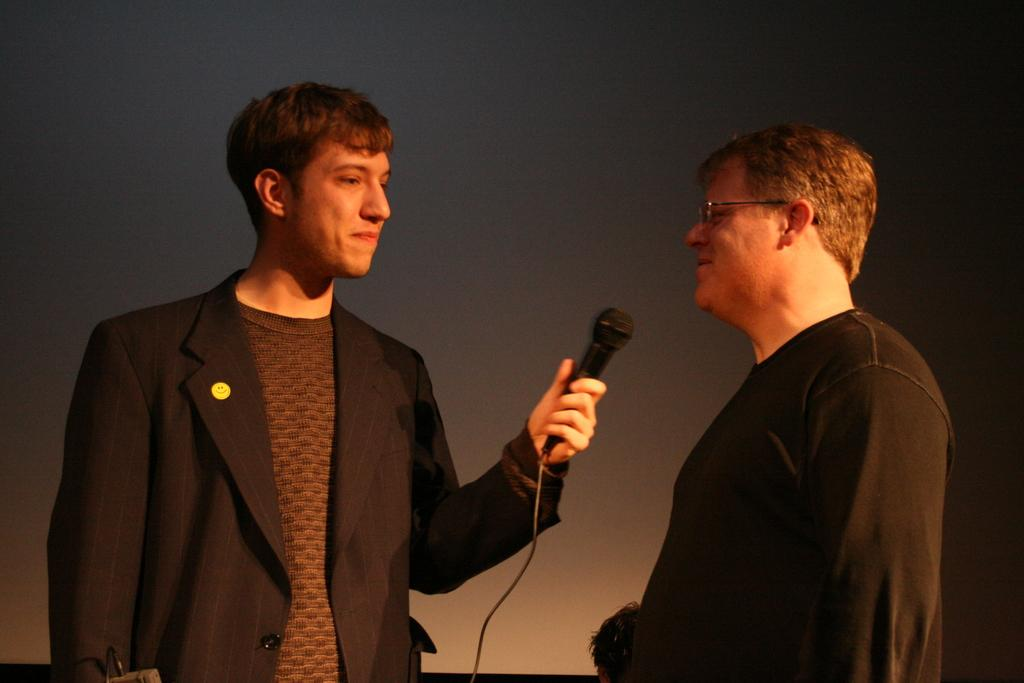How many people are in the image? There are two persons in the image. What are the two persons wearing? One person is wearing a black suit, and the other person is wearing a t-shirt. Can you describe what one of the persons is holding? One of the persons is holding a microphone. What type of teeth can be seen in the image? There are no teeth visible in the image. Is there any sleet present in the image? There is no mention of sleet or any weather conditions in the image. 